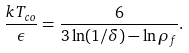Convert formula to latex. <formula><loc_0><loc_0><loc_500><loc_500>\frac { k T _ { c o } } { \epsilon } = \frac { 6 } { 3 \ln ( 1 / \delta ) - \ln \rho _ { f } } .</formula> 